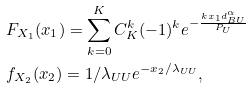Convert formula to latex. <formula><loc_0><loc_0><loc_500><loc_500>& F _ { X _ { 1 } } ( x _ { 1 } ) = \sum ^ { K } _ { k = 0 } C ^ { k } _ { K } ( - 1 ) ^ { k } e ^ { - \frac { k x _ { 1 } d _ { B U } ^ { \alpha } } { P _ { U } } } \\ & f _ { X _ { 2 } } ( x _ { 2 } ) = 1 / \lambda _ { U U } e ^ { - x _ { 2 } / \lambda _ { U U } } ,</formula> 